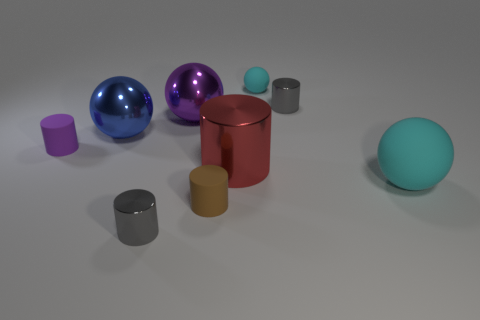There is a big blue thing; what shape is it?
Your answer should be compact. Sphere. What is the color of the large object to the left of the gray thing that is in front of the purple matte thing?
Give a very brief answer. Blue. There is a big cylinder; does it have the same color as the tiny shiny cylinder that is behind the big red metallic cylinder?
Provide a short and direct response. No. The large thing that is to the left of the big cyan matte sphere and in front of the blue shiny object is made of what material?
Your answer should be compact. Metal. Are there any gray cubes of the same size as the purple shiny sphere?
Provide a short and direct response. No. There is a cyan ball that is the same size as the brown object; what is it made of?
Make the answer very short. Rubber. What number of gray shiny cylinders are behind the small brown rubber cylinder?
Ensure brevity in your answer.  1. Is the shape of the tiny matte thing that is behind the large purple ball the same as  the large red object?
Make the answer very short. No. Is there a cyan metal thing that has the same shape as the brown thing?
Your answer should be very brief. No. There is a thing that is the same color as the tiny matte ball; what is its material?
Give a very brief answer. Rubber. 